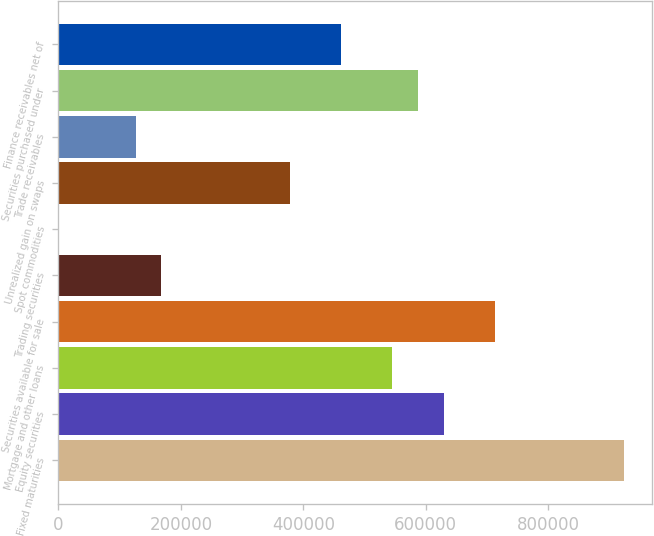Convert chart to OTSL. <chart><loc_0><loc_0><loc_500><loc_500><bar_chart><fcel>Fixed maturities<fcel>Equity securities<fcel>Mortgage and other loans<fcel>Securities available for sale<fcel>Trading securities<fcel>Spot commodities<fcel>Unrealized gain on swaps<fcel>Trade receivables<fcel>Securities purchased under<fcel>Finance receivables net of<nl><fcel>923426<fcel>629678<fcel>545751<fcel>713606<fcel>168076<fcel>220<fcel>377895<fcel>126112<fcel>587715<fcel>461823<nl></chart> 